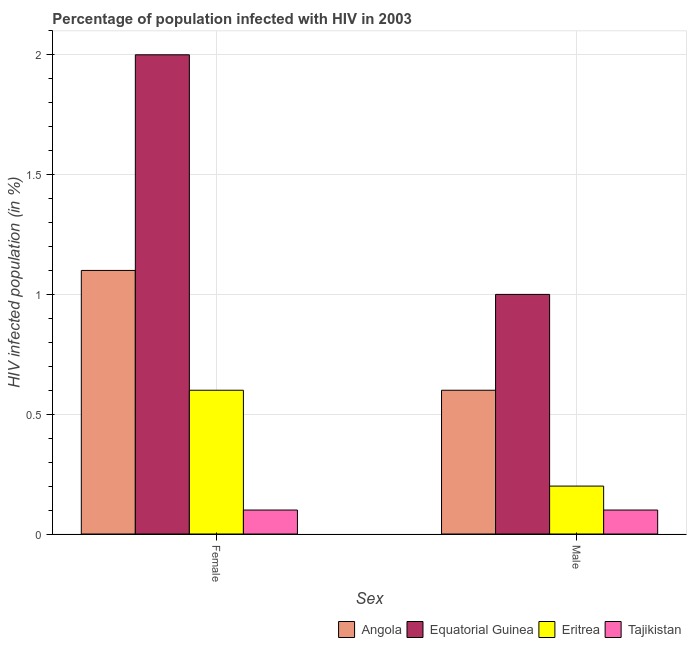Are the number of bars per tick equal to the number of legend labels?
Ensure brevity in your answer.  Yes. Are the number of bars on each tick of the X-axis equal?
Offer a terse response. Yes. How many bars are there on the 2nd tick from the left?
Provide a short and direct response. 4. Across all countries, what is the maximum percentage of males who are infected with hiv?
Provide a succinct answer. 1. Across all countries, what is the minimum percentage of females who are infected with hiv?
Your answer should be very brief. 0.1. In which country was the percentage of females who are infected with hiv maximum?
Offer a terse response. Equatorial Guinea. In which country was the percentage of females who are infected with hiv minimum?
Offer a terse response. Tajikistan. What is the total percentage of males who are infected with hiv in the graph?
Ensure brevity in your answer.  1.9. What is the average percentage of females who are infected with hiv per country?
Keep it short and to the point. 0.95. What is the difference between the percentage of males who are infected with hiv and percentage of females who are infected with hiv in Eritrea?
Provide a succinct answer. -0.4. In how many countries, is the percentage of males who are infected with hiv greater than 0.5 %?
Give a very brief answer. 2. What is the ratio of the percentage of females who are infected with hiv in Tajikistan to that in Angola?
Keep it short and to the point. 0.09. Is the percentage of males who are infected with hiv in Eritrea less than that in Equatorial Guinea?
Offer a terse response. Yes. What does the 3rd bar from the left in Male represents?
Your response must be concise. Eritrea. What does the 2nd bar from the right in Male represents?
Keep it short and to the point. Eritrea. How many bars are there?
Give a very brief answer. 8. Are all the bars in the graph horizontal?
Provide a succinct answer. No. How many countries are there in the graph?
Keep it short and to the point. 4. What is the difference between two consecutive major ticks on the Y-axis?
Offer a very short reply. 0.5. Does the graph contain any zero values?
Keep it short and to the point. No. What is the title of the graph?
Give a very brief answer. Percentage of population infected with HIV in 2003. Does "Spain" appear as one of the legend labels in the graph?
Your answer should be compact. No. What is the label or title of the X-axis?
Give a very brief answer. Sex. What is the label or title of the Y-axis?
Make the answer very short. HIV infected population (in %). What is the HIV infected population (in %) of Angola in Female?
Offer a terse response. 1.1. What is the HIV infected population (in %) in Equatorial Guinea in Female?
Offer a terse response. 2. What is the HIV infected population (in %) in Eritrea in Female?
Your response must be concise. 0.6. What is the HIV infected population (in %) in Tajikistan in Female?
Your answer should be very brief. 0.1. What is the HIV infected population (in %) of Angola in Male?
Keep it short and to the point. 0.6. Across all Sex, what is the maximum HIV infected population (in %) of Angola?
Your answer should be compact. 1.1. Across all Sex, what is the maximum HIV infected population (in %) in Eritrea?
Make the answer very short. 0.6. Across all Sex, what is the maximum HIV infected population (in %) of Tajikistan?
Provide a short and direct response. 0.1. Across all Sex, what is the minimum HIV infected population (in %) of Angola?
Provide a succinct answer. 0.6. Across all Sex, what is the minimum HIV infected population (in %) in Eritrea?
Your answer should be very brief. 0.2. Across all Sex, what is the minimum HIV infected population (in %) of Tajikistan?
Keep it short and to the point. 0.1. What is the difference between the HIV infected population (in %) in Angola in Female and that in Male?
Keep it short and to the point. 0.5. What is the difference between the HIV infected population (in %) of Equatorial Guinea in Female and that in Male?
Offer a very short reply. 1. What is the difference between the HIV infected population (in %) in Eritrea in Female and that in Male?
Keep it short and to the point. 0.4. What is the difference between the HIV infected population (in %) of Angola in Female and the HIV infected population (in %) of Equatorial Guinea in Male?
Your answer should be very brief. 0.1. What is the difference between the HIV infected population (in %) in Angola in Female and the HIV infected population (in %) in Eritrea in Male?
Your answer should be compact. 0.9. What is the difference between the HIV infected population (in %) in Equatorial Guinea in Female and the HIV infected population (in %) in Eritrea in Male?
Give a very brief answer. 1.8. What is the difference between the HIV infected population (in %) of Equatorial Guinea in Female and the HIV infected population (in %) of Tajikistan in Male?
Offer a terse response. 1.9. What is the average HIV infected population (in %) of Angola per Sex?
Make the answer very short. 0.85. What is the average HIV infected population (in %) in Equatorial Guinea per Sex?
Provide a succinct answer. 1.5. What is the average HIV infected population (in %) of Tajikistan per Sex?
Keep it short and to the point. 0.1. What is the difference between the HIV infected population (in %) in Angola and HIV infected population (in %) in Eritrea in Female?
Offer a very short reply. 0.5. What is the difference between the HIV infected population (in %) of Angola and HIV infected population (in %) of Tajikistan in Female?
Offer a very short reply. 1. What is the difference between the HIV infected population (in %) in Equatorial Guinea and HIV infected population (in %) in Tajikistan in Female?
Your answer should be very brief. 1.9. What is the difference between the HIV infected population (in %) of Eritrea and HIV infected population (in %) of Tajikistan in Female?
Keep it short and to the point. 0.5. What is the difference between the HIV infected population (in %) of Angola and HIV infected population (in %) of Equatorial Guinea in Male?
Ensure brevity in your answer.  -0.4. What is the difference between the HIV infected population (in %) in Eritrea and HIV infected population (in %) in Tajikistan in Male?
Your answer should be compact. 0.1. What is the ratio of the HIV infected population (in %) of Angola in Female to that in Male?
Offer a very short reply. 1.83. What is the ratio of the HIV infected population (in %) in Equatorial Guinea in Female to that in Male?
Your answer should be compact. 2. What is the difference between the highest and the second highest HIV infected population (in %) in Equatorial Guinea?
Make the answer very short. 1. What is the difference between the highest and the second highest HIV infected population (in %) of Eritrea?
Offer a terse response. 0.4. What is the difference between the highest and the second highest HIV infected population (in %) in Tajikistan?
Give a very brief answer. 0. What is the difference between the highest and the lowest HIV infected population (in %) in Equatorial Guinea?
Offer a terse response. 1. What is the difference between the highest and the lowest HIV infected population (in %) in Eritrea?
Make the answer very short. 0.4. What is the difference between the highest and the lowest HIV infected population (in %) of Tajikistan?
Provide a succinct answer. 0. 